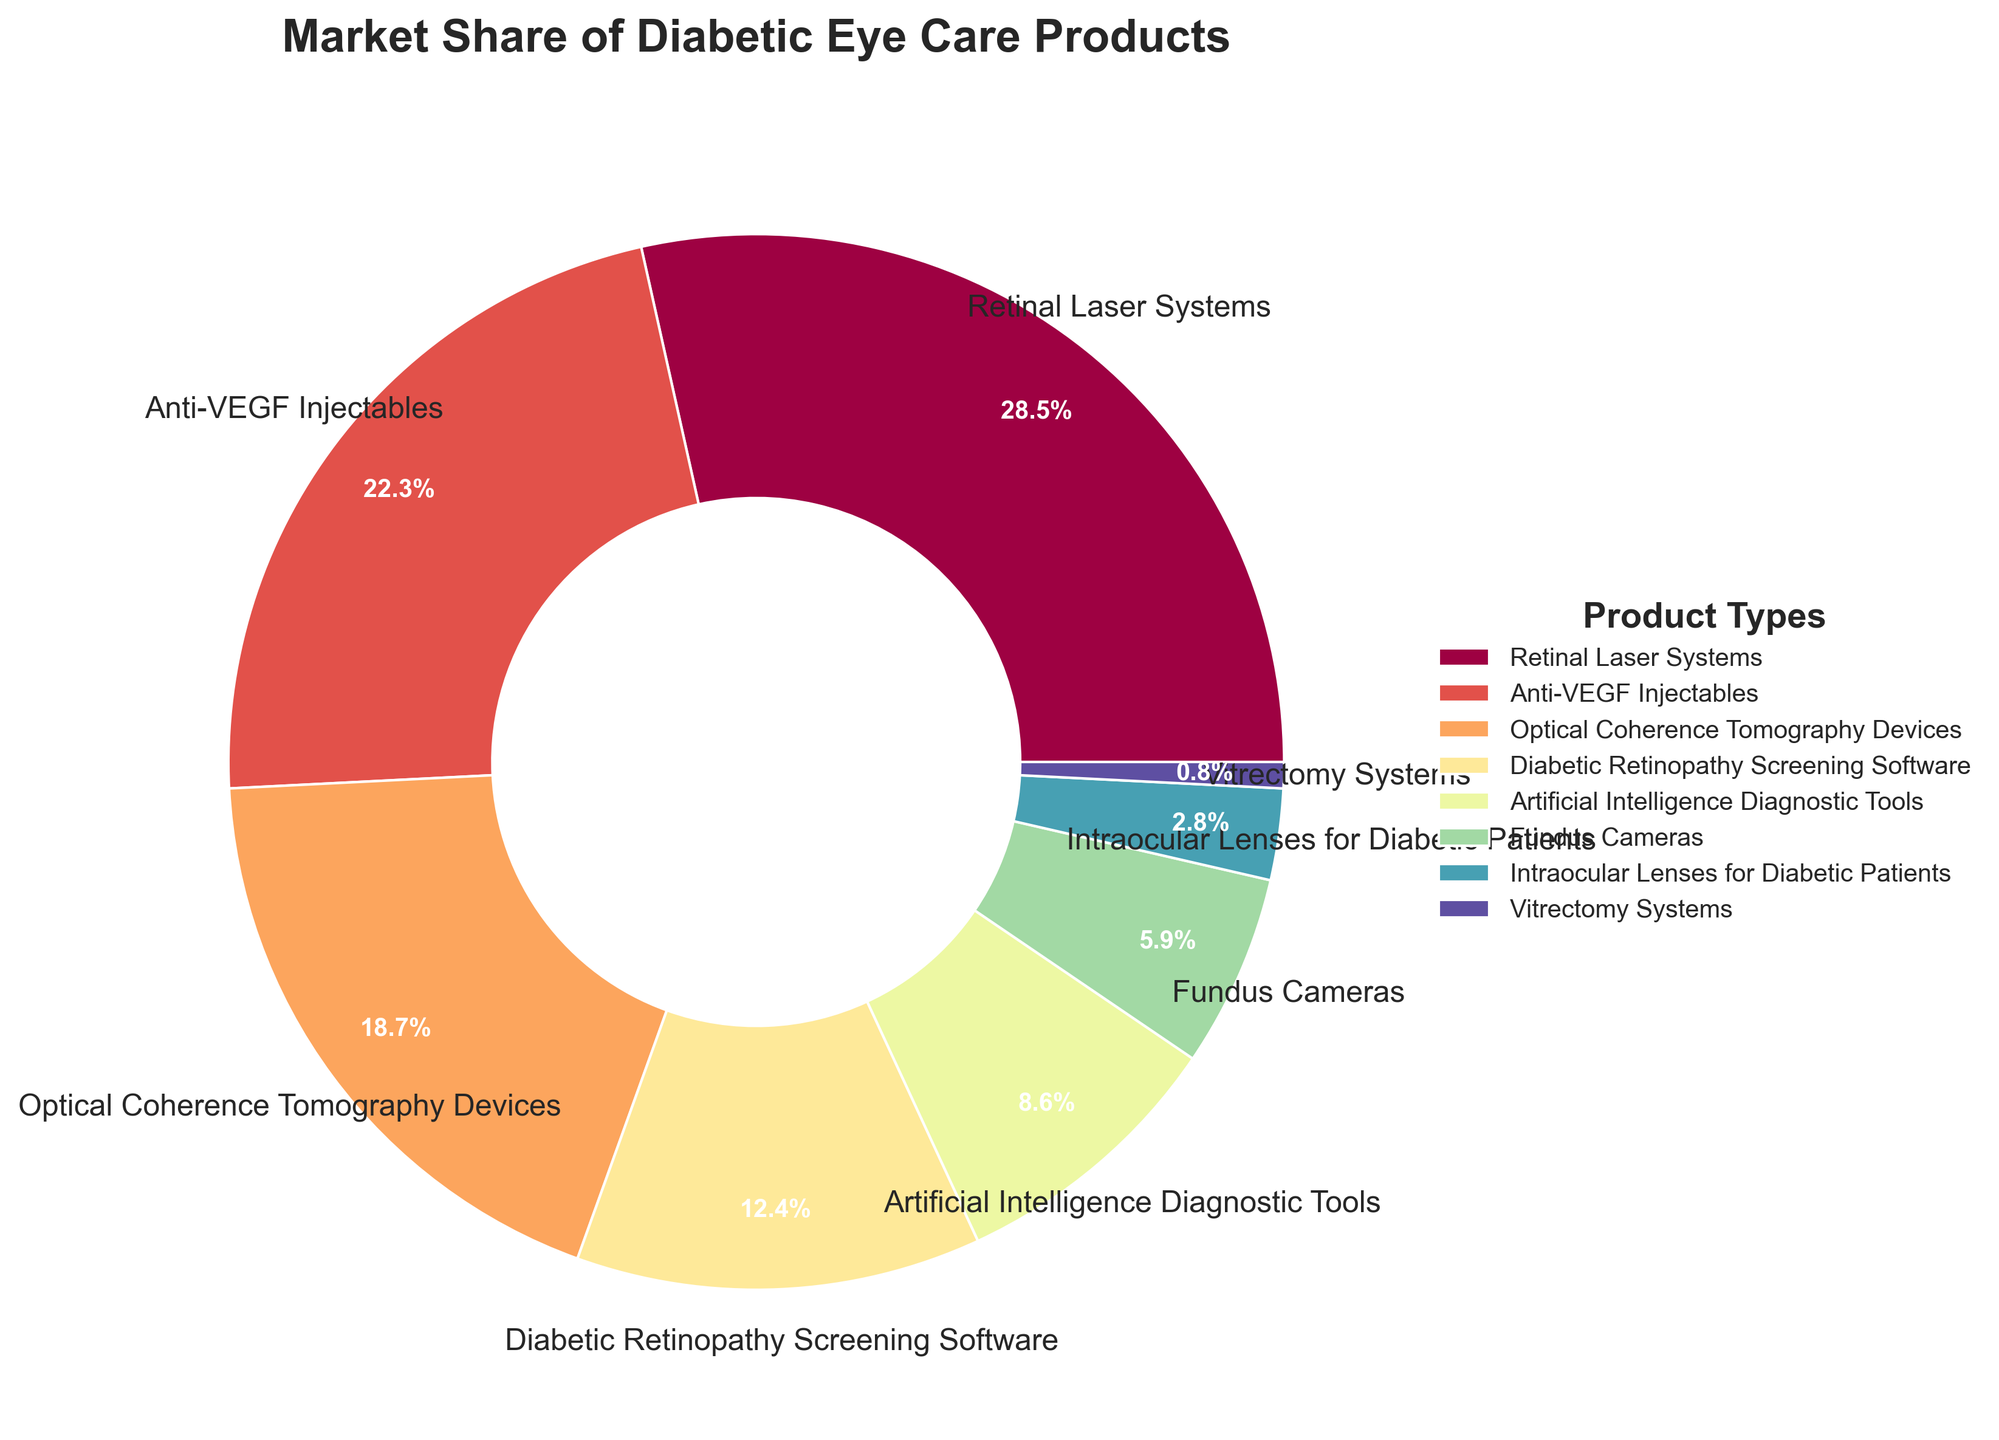What is the product type with the highest market share? The largest section of the pie chart represents the product type with the highest market share. By looking at the chart, the section labeled "Retinal Laser Systems" appears the largest.
Answer: Retinal Laser Systems What is the combined market share of Anti-VEGF Injectables and Optical Coherence Tomography Devices? To find the combined market share, sum the market shares of both product types: 22.3% (Anti-VEGF Injectables) + 18.7% (Optical Coherence Tomography Devices) = 41.0%.
Answer: 41.0% How does the market share of Fundus Cameras compare to that of Diabetic Retinopathy Screening Software? Compare the market share percentages: Fundus Cameras (5.9%) are less than Diabetic Retinopathy Screening Software (12.4%).
Answer: Fundus Cameras have a lower market share Which product type has the smallest market share? Identify the smallest segment in the pie chart, which is marked by the label "Vitrectomy Systems".
Answer: Vitrectomy Systems What is the market share difference between the product type with the highest share and the product type with the smallest share? Calculate the difference between the highest (Retinal Laser Systems, 28.5%) and the smallest (Vitrectomy Systems, 0.8%) market share values: 28.5% - 0.8% = 27.7%.
Answer: 27.7% Which product type occupies close to a quarter of the market share? A quarter of the market share is 25%. The segment for Retinal Laser Systems (28.5%) is closest to this value.
Answer: Retinal Laser Systems What is the product type with the market share represented by a dark blue segment in the pie chart? Visual identification might be necessary. Look for the color scheme in the chart and match it with the respective segment. The dark blue segment is labeled with "Optical Coherence Tomography Devices".
Answer: Optical Coherence Tomography Devices What is the total market share of products with more than 10% share? Sum the market shares of product types with more than 10%: Retinal Laser Systems (28.5%) + Anti-VEGF Injectables (22.3%) + Optical Coherence Tomography Devices (18.7%) + Diabetic Retinopathy Screening Software (12.4%) = 81.9%.
Answer: 81.9% Is the market share for Artificial Intelligence Diagnostic Tools greater than, less than, or equal to 10%? Compare the market share of Artificial Intelligence Diagnostic Tools (8.6%) to 10%. 8.6% is less than 10%.
Answer: Less than 10% What is the average market share for the top three product types? Calculate the average of the market shares of the top three products: Retinal Laser Systems (28.5%), Anti-VEGF Injectables (22.3%), and Optical Coherence Tomography Devices (18.7%). Sum these values: 28.5% + 22.3% + 18.7% = 69.5%, then divide by 3, resulting in 69.5% / 3 ≈ 23.2%.
Answer: 23.2% 